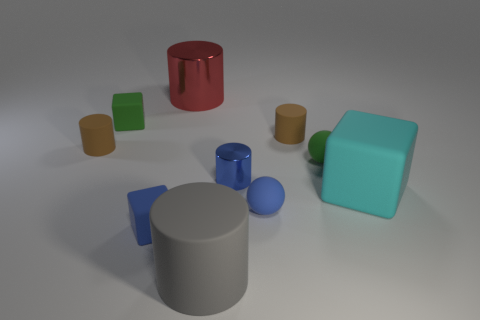Subtract all large blocks. How many blocks are left? 2 Subtract all blue balls. How many balls are left? 1 Subtract all balls. How many objects are left? 8 Subtract 2 balls. How many balls are left? 0 Subtract all cyan blocks. Subtract all gray spheres. How many blocks are left? 2 Subtract all blue cubes. How many cyan cylinders are left? 0 Subtract all big shiny cylinders. Subtract all blue spheres. How many objects are left? 8 Add 1 green rubber spheres. How many green rubber spheres are left? 2 Add 4 tiny green rubber objects. How many tiny green rubber objects exist? 6 Subtract 0 yellow cylinders. How many objects are left? 10 